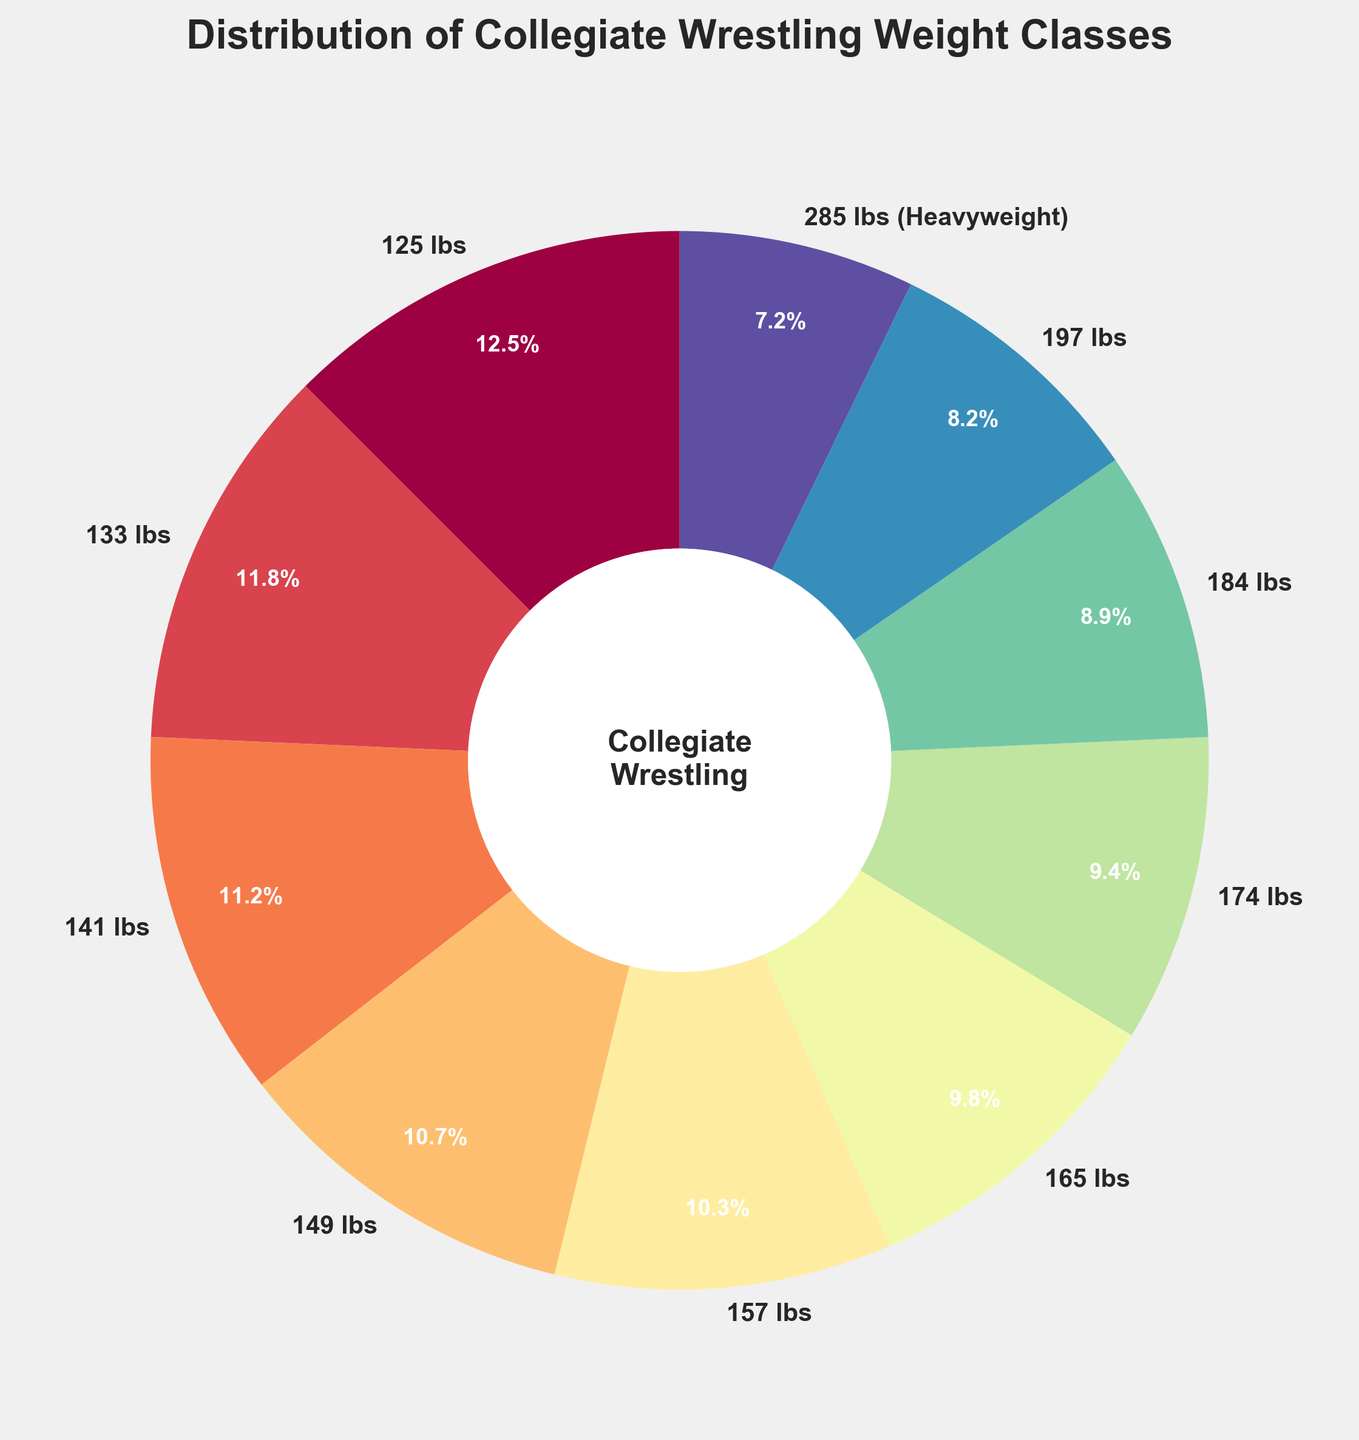what’s the weight class with the largest percentage? We can look at the segments of the pie chart and identify the weight class occupying the largest area. The 125 lbs weight class takes up the largest segment with 12.5%.
Answer: 125 lbs Which weight class has the smallest percentage? We check the segment with the smallest section on the pie chart. The 285 lbs (Heavyweight) class is the smallest with 7.2%.
Answer: 285 lbs (Heavyweight) What is the total percentage of weight classes under 150 lbs? To find this, we add up the percentages of the weight classes 125 lbs, 133 lbs, 141 lbs, and 149 lbs. (12.5 + 11.8 + 11.2 + 10.7) = 46.2%.
Answer: 46.2% Is the percentage of the 197 lbs class greater than the 184 lbs class? We compare the two segments on the pie chart. The 197 lbs class is 8.2%, which is less than the 184 lbs class at 8.9%.
Answer: No What is the difference in percentage between the 157 lbs and 165 lbs classes? We subtract the percentage of the 165 lbs class from the 157 lbs class. The 157 lbs class is 10.3% and the 165 lbs class is 9.8%. So, 10.3% - 9.8% = 0.5%.
Answer: 0.5% How do the middleweight classes (157 lbs, 165 lbs, 174 lbs) compare in total to the heavyweight class (285 lbs)? We add the percentages of the middleweight classes and compare to the heavyweight class. (10.3 + 9.8 + 9.4) = 29.5%, which is significantly larger than 7.2%.
Answer: Middleweight classes What weight class would the second largest segment correspond to? The pie chart’s second largest segment represents the 133 lbs class at 11.8%.
Answer: 133 lbs What is the total percentage of weight classes over 174 lbs? We sum the percentages for 184 lbs, 197 lbs, and 285 lbs classes. (8.9 + 8.2 + 7.2) = 24.3%.
Answer: 24.3% Which two weight classes are most similar in percentage? By visually comparing the segments, the most similar are the 165 lbs class (9.8%) and the 174 lbs class (9.4%), with only a 0.4% difference.
Answer: 165 lbs and 174 lbs 